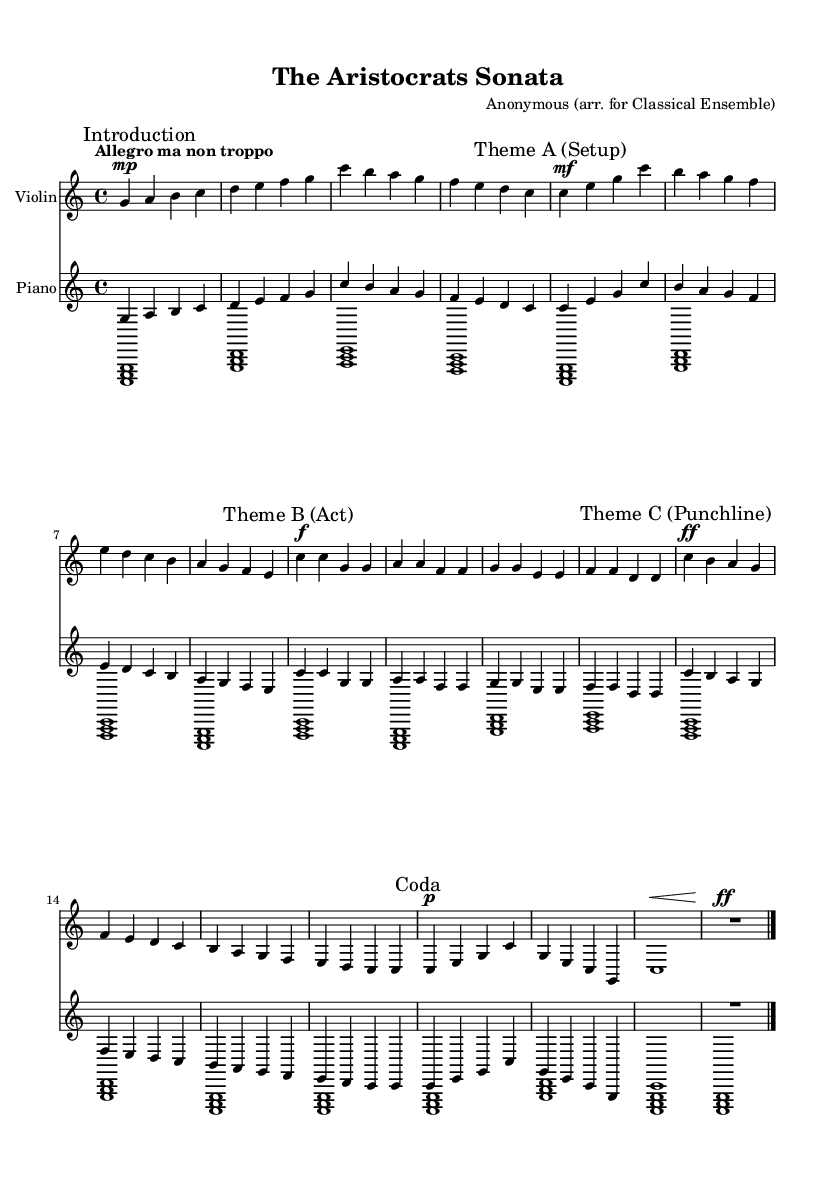What is the key signature of this music? The key signature is indicated at the beginning of the staff. There are no sharps or flats shown, confirming it is C major.
Answer: C major What is the time signature of this music? The time signature is indicated at the beginning of the piece, shown as 4/4, which means there are four beats per measure.
Answer: 4/4 What is the tempo marking of this piece? The tempo marking is located in the initial part of the score and it reads "Allegro ma non troppo", suggesting a fast pace but not excessively so.
Answer: Allegro ma non troppo How many themes are present in this composition? By examining the structure of the piece, it is divided into three distinct thematic sections: Theme A, Theme B, and Theme C.
Answer: Three What dynamic marking is indicated at the punchline of Theme C? The punchline of Theme C has a dynamic marking that indicates a fortissimo (ff) which directs the musician to play very loudly, emphasizing the comedic effect.
Answer: Fortissimo What is the overall structure of the piece? The piece has an introduction, followed by three themed sections, and concludes with a coda. The sections are labeled clearly within the score, illustrating its structure.
Answer: Introduction, Theme A, Theme B, Theme C, Coda What instrument accompanies the violin in this score? The score features a piano, providing harmonic support and counterpoint to the violin melody throughout the piece.
Answer: Piano 